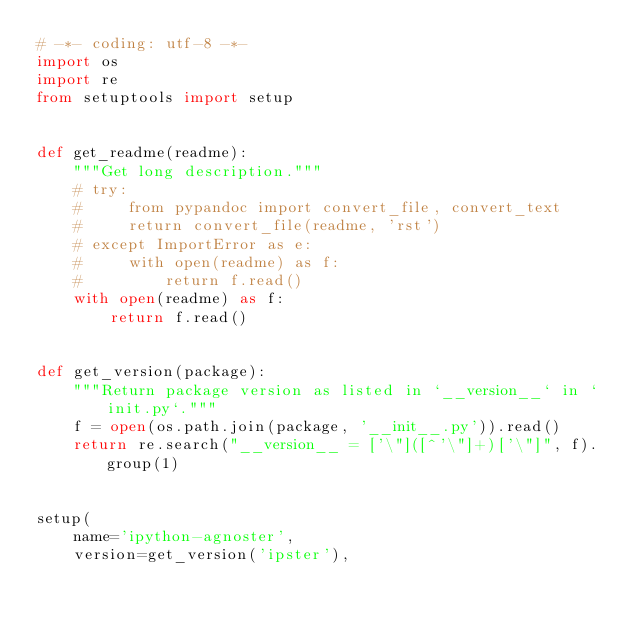<code> <loc_0><loc_0><loc_500><loc_500><_Python_># -*- coding: utf-8 -*-
import os
import re
from setuptools import setup


def get_readme(readme):
    """Get long description."""
    # try:
    #     from pypandoc import convert_file, convert_text
    #     return convert_file(readme, 'rst')
    # except ImportError as e:
    #     with open(readme) as f:
    #         return f.read()
    with open(readme) as f:
        return f.read()


def get_version(package):
    """Return package version as listed in `__version__` in `init.py`."""
    f = open(os.path.join(package, '__init__.py')).read()
    return re.search("__version__ = ['\"]([^'\"]+)['\"]", f).group(1)


setup(
    name='ipython-agnoster',
    version=get_version('ipster'),</code> 